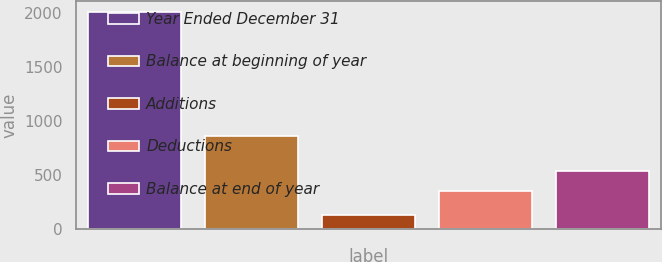<chart> <loc_0><loc_0><loc_500><loc_500><bar_chart><fcel>Year Ended December 31<fcel>Balance at beginning of year<fcel>Additions<fcel>Deductions<fcel>Balance at end of year<nl><fcel>2012<fcel>859<fcel>126<fcel>352<fcel>540.6<nl></chart> 